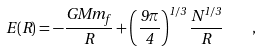<formula> <loc_0><loc_0><loc_500><loc_500>E ( R ) = - \frac { G M m _ { f } } { R } + \left ( \frac { 9 \pi } { 4 } \right ) ^ { 1 / 3 } \frac { N ^ { 1 / 3 } } { R } \quad ,</formula> 